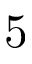<formula> <loc_0><loc_0><loc_500><loc_500>5</formula> 